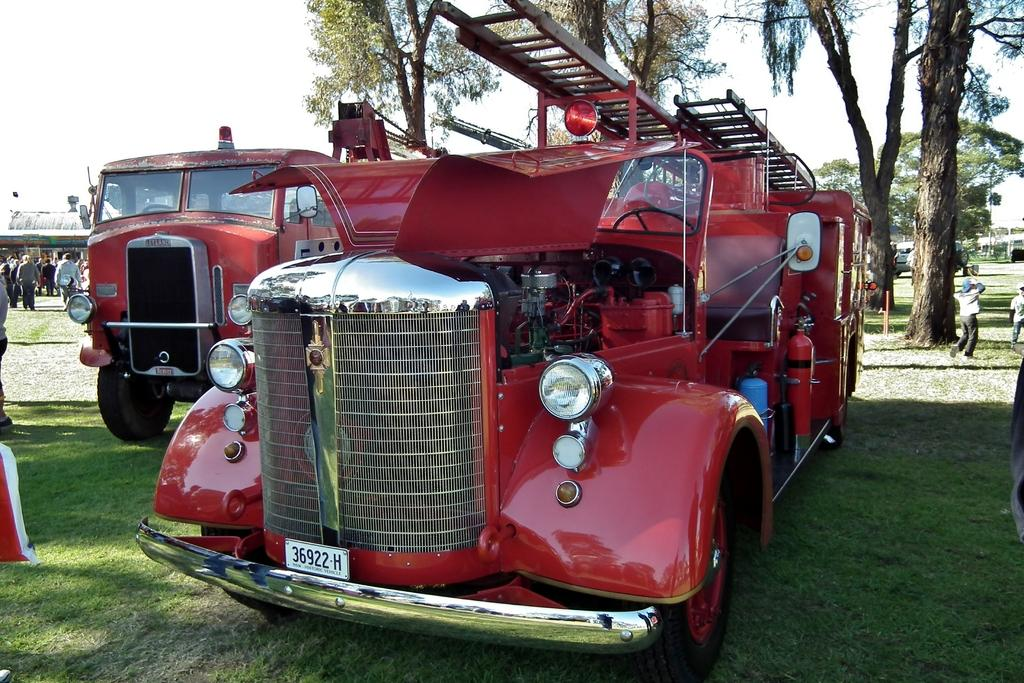What is the main subject of the image? There is a group of people in the image. What else can be seen in the image besides the people? There are vehicles on the grass in the image, and they are red. What can be seen in the background of the image? There are trees and buildings in the background of the image. What type of silver material is present in the image? There is no silver material present in the image. How does the expansion of the vehicles affect the image? The vehicles are not expanding in the image, and their size does not change. 